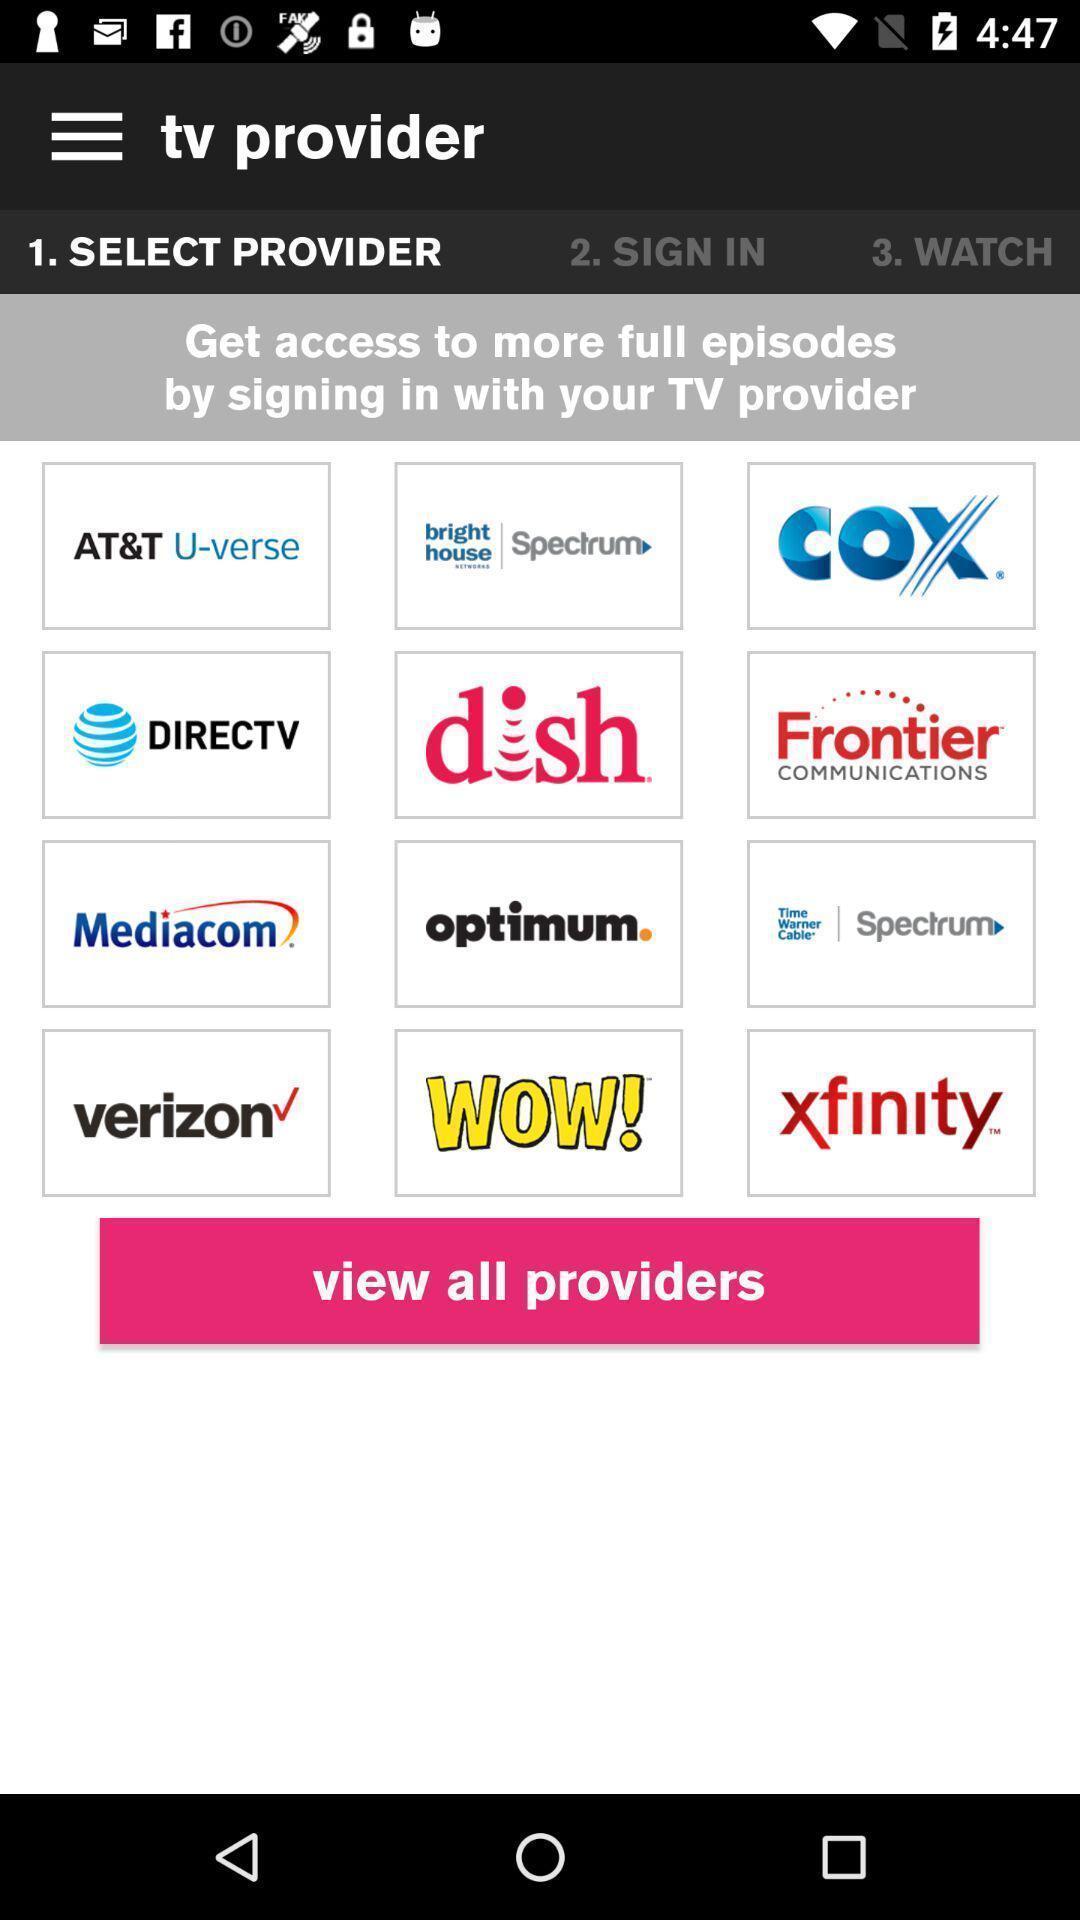Describe the key features of this screenshot. Starting page. 